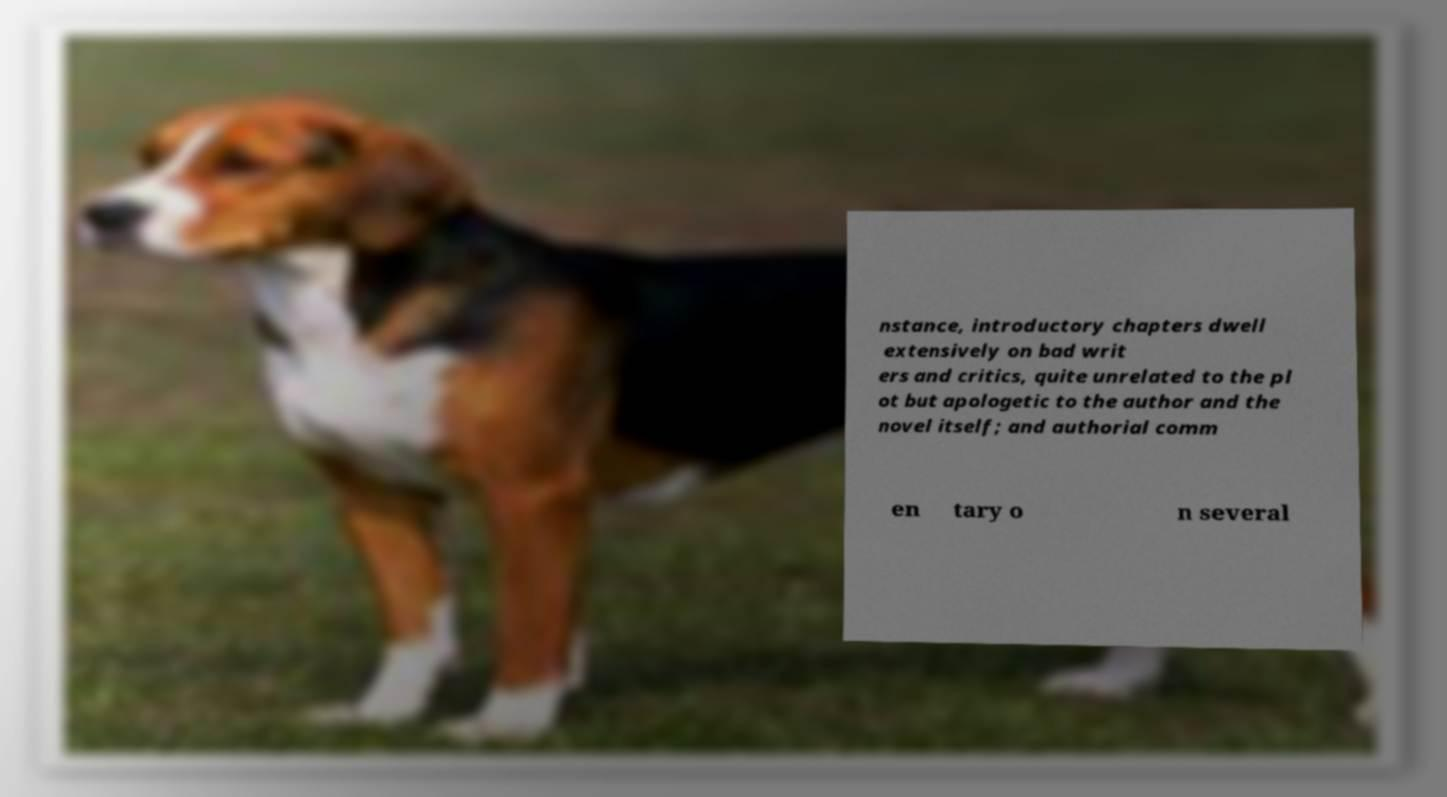Can you read and provide the text displayed in the image?This photo seems to have some interesting text. Can you extract and type it out for me? nstance, introductory chapters dwell extensively on bad writ ers and critics, quite unrelated to the pl ot but apologetic to the author and the novel itself; and authorial comm en tary o n several 